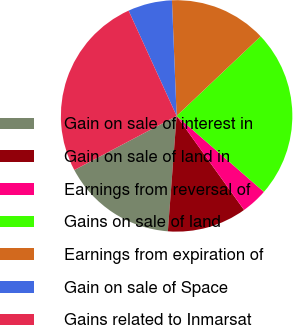Convert chart to OTSL. <chart><loc_0><loc_0><loc_500><loc_500><pie_chart><fcel>Gain on sale of interest in<fcel>Gain on sale of land in<fcel>Earnings from reversal of<fcel>Gains on sale of land<fcel>Earnings from expiration of<fcel>Gain on sale of Space<fcel>Gains related to Inmarsat<nl><fcel>16.05%<fcel>11.11%<fcel>3.7%<fcel>23.46%<fcel>13.58%<fcel>6.17%<fcel>25.93%<nl></chart> 